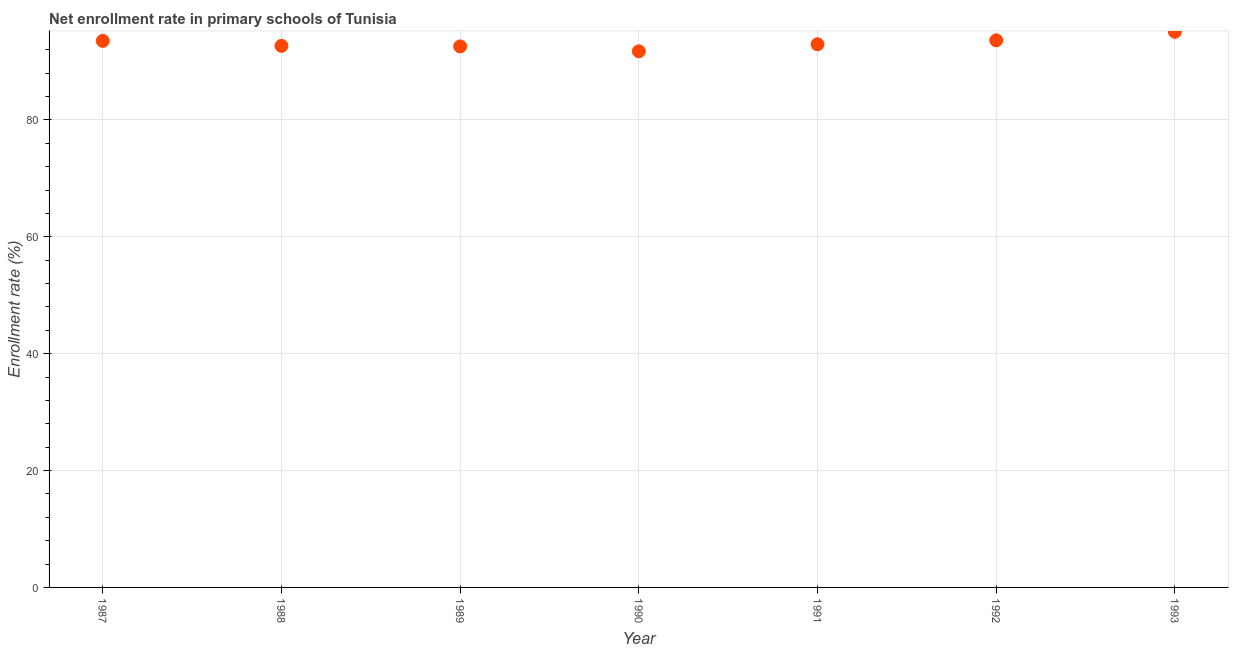What is the net enrollment rate in primary schools in 1993?
Provide a succinct answer. 95.09. Across all years, what is the maximum net enrollment rate in primary schools?
Your response must be concise. 95.09. Across all years, what is the minimum net enrollment rate in primary schools?
Your response must be concise. 91.75. In which year was the net enrollment rate in primary schools maximum?
Your answer should be very brief. 1993. What is the sum of the net enrollment rate in primary schools?
Your answer should be very brief. 652.22. What is the difference between the net enrollment rate in primary schools in 1991 and 1993?
Ensure brevity in your answer.  -2.13. What is the average net enrollment rate in primary schools per year?
Your answer should be compact. 93.17. What is the median net enrollment rate in primary schools?
Offer a terse response. 92.96. Do a majority of the years between 1993 and 1988 (inclusive) have net enrollment rate in primary schools greater than 24 %?
Your response must be concise. Yes. What is the ratio of the net enrollment rate in primary schools in 1987 to that in 1993?
Your response must be concise. 0.98. Is the difference between the net enrollment rate in primary schools in 1989 and 1991 greater than the difference between any two years?
Offer a terse response. No. What is the difference between the highest and the second highest net enrollment rate in primary schools?
Offer a very short reply. 1.46. Is the sum of the net enrollment rate in primary schools in 1989 and 1992 greater than the maximum net enrollment rate in primary schools across all years?
Provide a succinct answer. Yes. What is the difference between the highest and the lowest net enrollment rate in primary schools?
Your answer should be very brief. 3.33. In how many years, is the net enrollment rate in primary schools greater than the average net enrollment rate in primary schools taken over all years?
Your answer should be compact. 3. What is the difference between two consecutive major ticks on the Y-axis?
Offer a terse response. 20. Does the graph contain any zero values?
Keep it short and to the point. No. What is the title of the graph?
Give a very brief answer. Net enrollment rate in primary schools of Tunisia. What is the label or title of the Y-axis?
Offer a terse response. Enrollment rate (%). What is the Enrollment rate (%) in 1987?
Offer a terse response. 93.53. What is the Enrollment rate (%) in 1988?
Provide a succinct answer. 92.68. What is the Enrollment rate (%) in 1989?
Give a very brief answer. 92.59. What is the Enrollment rate (%) in 1990?
Ensure brevity in your answer.  91.75. What is the Enrollment rate (%) in 1991?
Give a very brief answer. 92.96. What is the Enrollment rate (%) in 1992?
Provide a short and direct response. 93.63. What is the Enrollment rate (%) in 1993?
Provide a succinct answer. 95.09. What is the difference between the Enrollment rate (%) in 1987 and 1988?
Keep it short and to the point. 0.85. What is the difference between the Enrollment rate (%) in 1987 and 1989?
Your answer should be compact. 0.95. What is the difference between the Enrollment rate (%) in 1987 and 1990?
Keep it short and to the point. 1.78. What is the difference between the Enrollment rate (%) in 1987 and 1991?
Ensure brevity in your answer.  0.58. What is the difference between the Enrollment rate (%) in 1987 and 1992?
Your response must be concise. -0.09. What is the difference between the Enrollment rate (%) in 1987 and 1993?
Offer a terse response. -1.55. What is the difference between the Enrollment rate (%) in 1988 and 1989?
Make the answer very short. 0.09. What is the difference between the Enrollment rate (%) in 1988 and 1990?
Provide a succinct answer. 0.93. What is the difference between the Enrollment rate (%) in 1988 and 1991?
Ensure brevity in your answer.  -0.28. What is the difference between the Enrollment rate (%) in 1988 and 1992?
Provide a succinct answer. -0.95. What is the difference between the Enrollment rate (%) in 1988 and 1993?
Your answer should be compact. -2.41. What is the difference between the Enrollment rate (%) in 1989 and 1990?
Provide a short and direct response. 0.83. What is the difference between the Enrollment rate (%) in 1989 and 1991?
Give a very brief answer. -0.37. What is the difference between the Enrollment rate (%) in 1989 and 1992?
Provide a short and direct response. -1.04. What is the difference between the Enrollment rate (%) in 1989 and 1993?
Provide a short and direct response. -2.5. What is the difference between the Enrollment rate (%) in 1990 and 1991?
Ensure brevity in your answer.  -1.2. What is the difference between the Enrollment rate (%) in 1990 and 1992?
Your answer should be very brief. -1.87. What is the difference between the Enrollment rate (%) in 1990 and 1993?
Your response must be concise. -3.33. What is the difference between the Enrollment rate (%) in 1991 and 1992?
Your answer should be very brief. -0.67. What is the difference between the Enrollment rate (%) in 1991 and 1993?
Provide a succinct answer. -2.13. What is the difference between the Enrollment rate (%) in 1992 and 1993?
Give a very brief answer. -1.46. What is the ratio of the Enrollment rate (%) in 1987 to that in 1988?
Your response must be concise. 1.01. What is the ratio of the Enrollment rate (%) in 1987 to that in 1989?
Provide a succinct answer. 1.01. What is the ratio of the Enrollment rate (%) in 1987 to that in 1990?
Provide a short and direct response. 1.02. What is the ratio of the Enrollment rate (%) in 1987 to that in 1993?
Ensure brevity in your answer.  0.98. What is the ratio of the Enrollment rate (%) in 1988 to that in 1989?
Your answer should be very brief. 1. What is the ratio of the Enrollment rate (%) in 1988 to that in 1990?
Provide a succinct answer. 1.01. What is the ratio of the Enrollment rate (%) in 1988 to that in 1993?
Provide a short and direct response. 0.97. What is the ratio of the Enrollment rate (%) in 1990 to that in 1991?
Make the answer very short. 0.99. What is the ratio of the Enrollment rate (%) in 1992 to that in 1993?
Offer a very short reply. 0.98. 